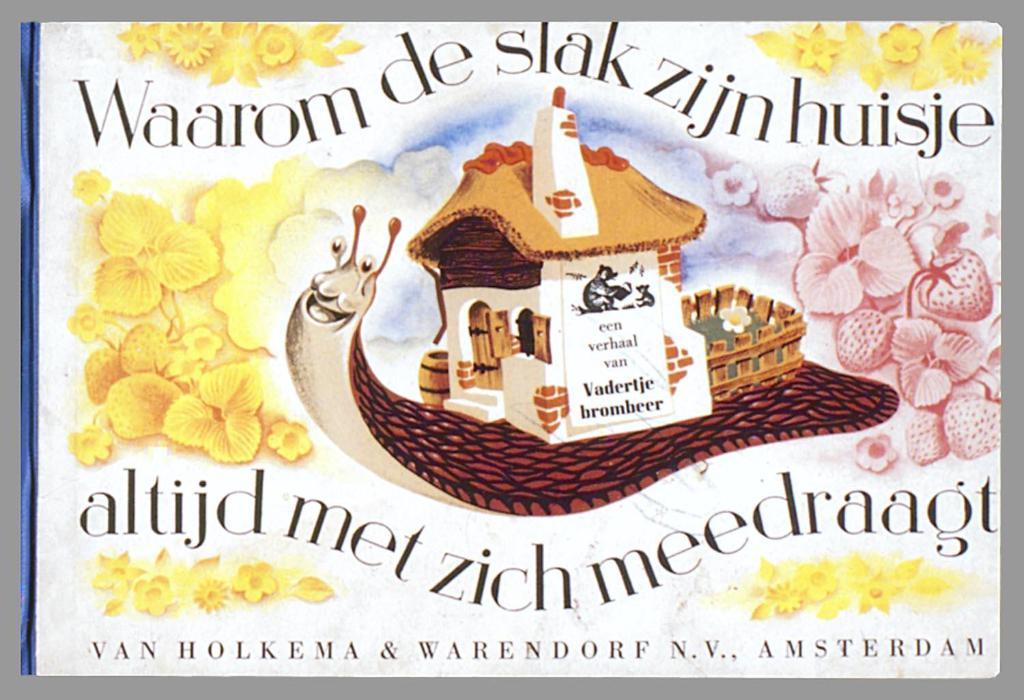Could you give a brief overview of what you see in this image? In this image I can see a poster in which flowers, text, house and a mammal is there. This image looks like a photo frame. 